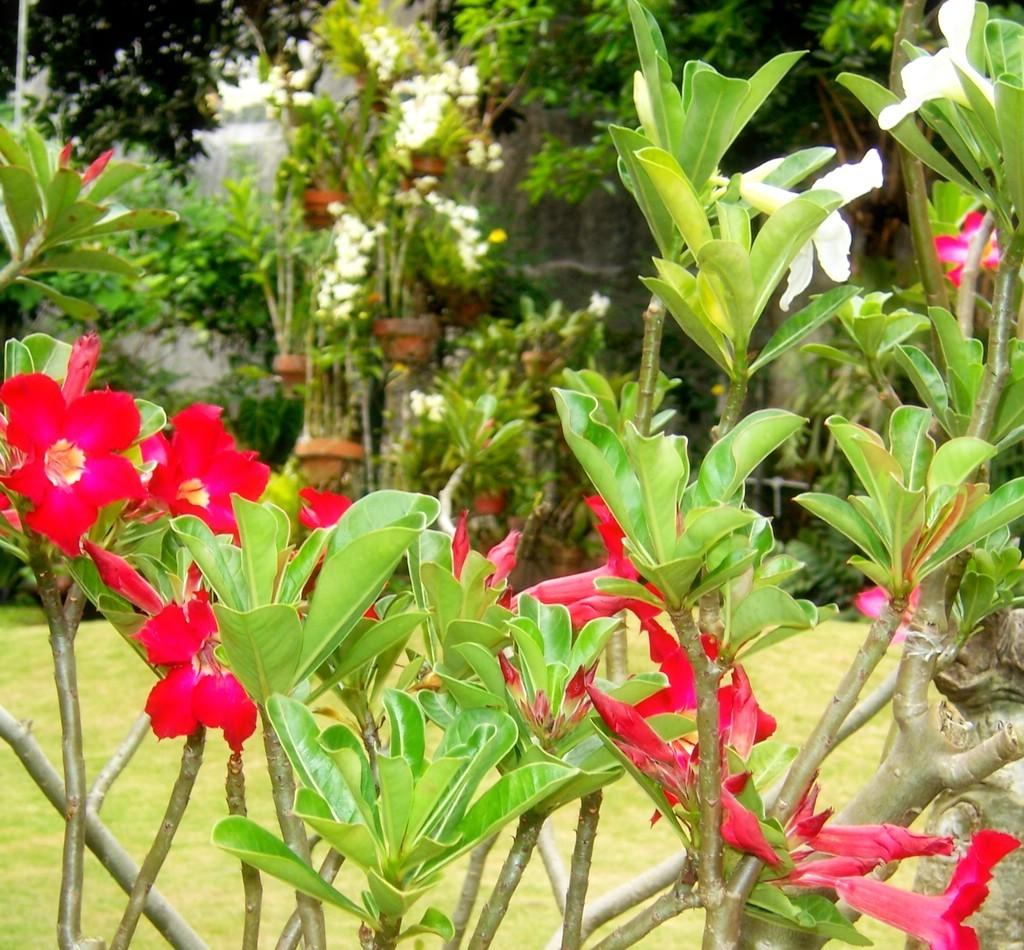What type of plant is visible in the image? There is a plant in the image, and it has flowers. What can be seen in the background of the image? There are trees in the background of the image. What type of story is being told by the zebra in the image? There is no zebra present in the image, so no story is being told. 